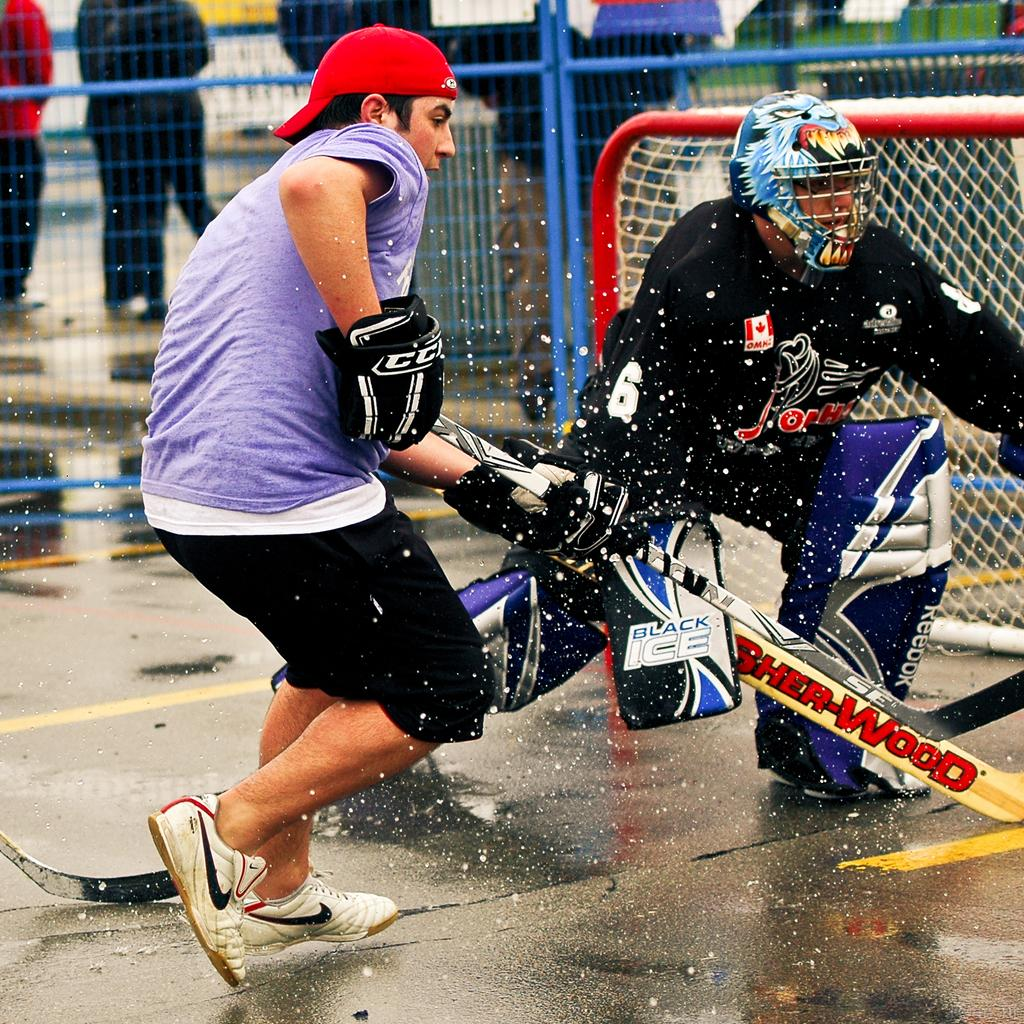What are the two people in the image doing? The two people in the image are playing. What are the people holding while playing? The people are holding sticks. What can be seen in the background of the image? There is a mesh and rods in the background of the image. Are there any other people visible in the image? Yes, there are other people visible in the background of the image. What type of lizards can be seen climbing on the mesh in the image? There are no lizards present in the image; it only features two people playing with sticks and a background with mesh and rods. How much profit can be made from the game being played in the image? There is no indication of any profit-making activity in the image, as it only shows two people playing with sticks. 